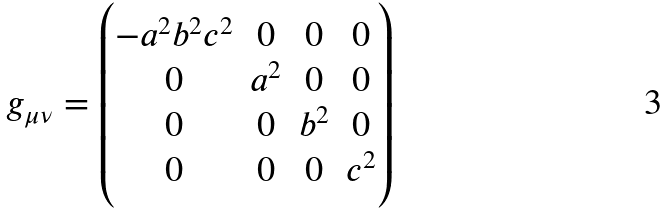<formula> <loc_0><loc_0><loc_500><loc_500>g _ { \mu \nu } = \begin{pmatrix} - a ^ { 2 } b ^ { 2 } c ^ { 2 } & 0 & 0 & 0 \\ 0 & a ^ { 2 } & 0 & 0 \\ 0 & 0 & b ^ { 2 } & 0 \\ 0 & 0 & 0 & c ^ { 2 } \end{pmatrix}</formula> 